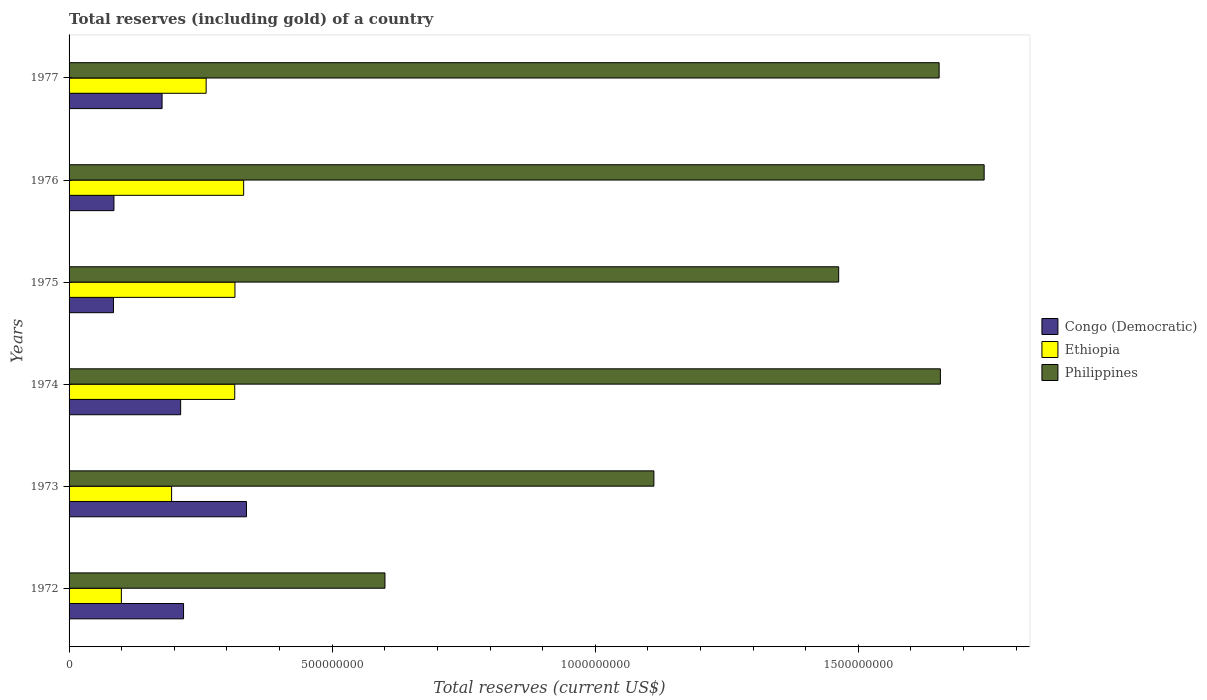How many different coloured bars are there?
Ensure brevity in your answer.  3. Are the number of bars per tick equal to the number of legend labels?
Make the answer very short. Yes. Are the number of bars on each tick of the Y-axis equal?
Keep it short and to the point. Yes. What is the label of the 2nd group of bars from the top?
Provide a succinct answer. 1976. In how many cases, is the number of bars for a given year not equal to the number of legend labels?
Give a very brief answer. 0. What is the total reserves (including gold) in Philippines in 1972?
Your answer should be very brief. 6.00e+08. Across all years, what is the maximum total reserves (including gold) in Congo (Democratic)?
Offer a terse response. 3.37e+08. Across all years, what is the minimum total reserves (including gold) in Congo (Democratic)?
Make the answer very short. 8.44e+07. In which year was the total reserves (including gold) in Philippines maximum?
Offer a very short reply. 1976. What is the total total reserves (including gold) in Congo (Democratic) in the graph?
Your answer should be compact. 1.11e+09. What is the difference between the total reserves (including gold) in Philippines in 1974 and that in 1975?
Your answer should be compact. 1.93e+08. What is the difference between the total reserves (including gold) in Philippines in 1975 and the total reserves (including gold) in Congo (Democratic) in 1976?
Provide a succinct answer. 1.38e+09. What is the average total reserves (including gold) in Philippines per year?
Your answer should be very brief. 1.37e+09. In the year 1975, what is the difference between the total reserves (including gold) in Philippines and total reserves (including gold) in Ethiopia?
Give a very brief answer. 1.15e+09. In how many years, is the total reserves (including gold) in Philippines greater than 500000000 US$?
Your answer should be very brief. 6. What is the ratio of the total reserves (including gold) in Philippines in 1975 to that in 1977?
Make the answer very short. 0.88. Is the total reserves (including gold) in Ethiopia in 1973 less than that in 1976?
Your response must be concise. Yes. What is the difference between the highest and the second highest total reserves (including gold) in Ethiopia?
Give a very brief answer. 1.65e+07. What is the difference between the highest and the lowest total reserves (including gold) in Philippines?
Keep it short and to the point. 1.14e+09. In how many years, is the total reserves (including gold) in Ethiopia greater than the average total reserves (including gold) in Ethiopia taken over all years?
Keep it short and to the point. 4. What does the 3rd bar from the top in 1973 represents?
Your answer should be very brief. Congo (Democratic). What does the 3rd bar from the bottom in 1976 represents?
Give a very brief answer. Philippines. Are all the bars in the graph horizontal?
Provide a short and direct response. Yes. What is the difference between two consecutive major ticks on the X-axis?
Give a very brief answer. 5.00e+08. Are the values on the major ticks of X-axis written in scientific E-notation?
Give a very brief answer. No. Does the graph contain any zero values?
Your response must be concise. No. Does the graph contain grids?
Ensure brevity in your answer.  No. Where does the legend appear in the graph?
Give a very brief answer. Center right. What is the title of the graph?
Your answer should be compact. Total reserves (including gold) of a country. What is the label or title of the X-axis?
Provide a succinct answer. Total reserves (current US$). What is the label or title of the Y-axis?
Keep it short and to the point. Years. What is the Total reserves (current US$) of Congo (Democratic) in 1972?
Your answer should be very brief. 2.18e+08. What is the Total reserves (current US$) of Ethiopia in 1972?
Offer a terse response. 9.94e+07. What is the Total reserves (current US$) in Philippines in 1972?
Ensure brevity in your answer.  6.00e+08. What is the Total reserves (current US$) of Congo (Democratic) in 1973?
Make the answer very short. 3.37e+08. What is the Total reserves (current US$) of Ethiopia in 1973?
Keep it short and to the point. 1.95e+08. What is the Total reserves (current US$) in Philippines in 1973?
Provide a succinct answer. 1.11e+09. What is the Total reserves (current US$) in Congo (Democratic) in 1974?
Your response must be concise. 2.12e+08. What is the Total reserves (current US$) in Ethiopia in 1974?
Your response must be concise. 3.15e+08. What is the Total reserves (current US$) in Philippines in 1974?
Give a very brief answer. 1.66e+09. What is the Total reserves (current US$) in Congo (Democratic) in 1975?
Provide a succinct answer. 8.44e+07. What is the Total reserves (current US$) in Ethiopia in 1975?
Ensure brevity in your answer.  3.15e+08. What is the Total reserves (current US$) of Philippines in 1975?
Your response must be concise. 1.46e+09. What is the Total reserves (current US$) of Congo (Democratic) in 1976?
Provide a succinct answer. 8.53e+07. What is the Total reserves (current US$) of Ethiopia in 1976?
Your answer should be very brief. 3.32e+08. What is the Total reserves (current US$) in Philippines in 1976?
Make the answer very short. 1.74e+09. What is the Total reserves (current US$) of Congo (Democratic) in 1977?
Your answer should be compact. 1.77e+08. What is the Total reserves (current US$) of Ethiopia in 1977?
Give a very brief answer. 2.60e+08. What is the Total reserves (current US$) of Philippines in 1977?
Offer a very short reply. 1.65e+09. Across all years, what is the maximum Total reserves (current US$) in Congo (Democratic)?
Your answer should be very brief. 3.37e+08. Across all years, what is the maximum Total reserves (current US$) in Ethiopia?
Provide a short and direct response. 3.32e+08. Across all years, what is the maximum Total reserves (current US$) of Philippines?
Your response must be concise. 1.74e+09. Across all years, what is the minimum Total reserves (current US$) of Congo (Democratic)?
Provide a short and direct response. 8.44e+07. Across all years, what is the minimum Total reserves (current US$) of Ethiopia?
Offer a terse response. 9.94e+07. Across all years, what is the minimum Total reserves (current US$) in Philippines?
Ensure brevity in your answer.  6.00e+08. What is the total Total reserves (current US$) of Congo (Democratic) in the graph?
Provide a succinct answer. 1.11e+09. What is the total Total reserves (current US$) of Ethiopia in the graph?
Your answer should be compact. 1.52e+09. What is the total Total reserves (current US$) in Philippines in the graph?
Provide a succinct answer. 8.22e+09. What is the difference between the Total reserves (current US$) of Congo (Democratic) in 1972 and that in 1973?
Provide a short and direct response. -1.20e+08. What is the difference between the Total reserves (current US$) in Ethiopia in 1972 and that in 1973?
Provide a succinct answer. -9.55e+07. What is the difference between the Total reserves (current US$) in Philippines in 1972 and that in 1973?
Provide a short and direct response. -5.11e+08. What is the difference between the Total reserves (current US$) in Congo (Democratic) in 1972 and that in 1974?
Ensure brevity in your answer.  5.50e+06. What is the difference between the Total reserves (current US$) in Ethiopia in 1972 and that in 1974?
Your response must be concise. -2.15e+08. What is the difference between the Total reserves (current US$) of Philippines in 1972 and that in 1974?
Offer a terse response. -1.06e+09. What is the difference between the Total reserves (current US$) in Congo (Democratic) in 1972 and that in 1975?
Ensure brevity in your answer.  1.33e+08. What is the difference between the Total reserves (current US$) of Ethiopia in 1972 and that in 1975?
Ensure brevity in your answer.  -2.16e+08. What is the difference between the Total reserves (current US$) in Philippines in 1972 and that in 1975?
Ensure brevity in your answer.  -8.62e+08. What is the difference between the Total reserves (current US$) in Congo (Democratic) in 1972 and that in 1976?
Make the answer very short. 1.32e+08. What is the difference between the Total reserves (current US$) of Ethiopia in 1972 and that in 1976?
Provide a short and direct response. -2.32e+08. What is the difference between the Total reserves (current US$) of Philippines in 1972 and that in 1976?
Keep it short and to the point. -1.14e+09. What is the difference between the Total reserves (current US$) of Congo (Democratic) in 1972 and that in 1977?
Ensure brevity in your answer.  4.08e+07. What is the difference between the Total reserves (current US$) in Ethiopia in 1972 and that in 1977?
Keep it short and to the point. -1.61e+08. What is the difference between the Total reserves (current US$) in Philippines in 1972 and that in 1977?
Your answer should be compact. -1.05e+09. What is the difference between the Total reserves (current US$) of Congo (Democratic) in 1973 and that in 1974?
Your response must be concise. 1.25e+08. What is the difference between the Total reserves (current US$) in Ethiopia in 1973 and that in 1974?
Ensure brevity in your answer.  -1.20e+08. What is the difference between the Total reserves (current US$) in Philippines in 1973 and that in 1974?
Your answer should be very brief. -5.44e+08. What is the difference between the Total reserves (current US$) in Congo (Democratic) in 1973 and that in 1975?
Provide a succinct answer. 2.53e+08. What is the difference between the Total reserves (current US$) in Ethiopia in 1973 and that in 1975?
Your answer should be very brief. -1.20e+08. What is the difference between the Total reserves (current US$) in Philippines in 1973 and that in 1975?
Give a very brief answer. -3.51e+08. What is the difference between the Total reserves (current US$) of Congo (Democratic) in 1973 and that in 1976?
Your answer should be compact. 2.52e+08. What is the difference between the Total reserves (current US$) of Ethiopia in 1973 and that in 1976?
Your response must be concise. -1.37e+08. What is the difference between the Total reserves (current US$) of Philippines in 1973 and that in 1976?
Keep it short and to the point. -6.28e+08. What is the difference between the Total reserves (current US$) of Congo (Democratic) in 1973 and that in 1977?
Provide a short and direct response. 1.60e+08. What is the difference between the Total reserves (current US$) of Ethiopia in 1973 and that in 1977?
Your answer should be very brief. -6.56e+07. What is the difference between the Total reserves (current US$) of Philippines in 1973 and that in 1977?
Your answer should be compact. -5.42e+08. What is the difference between the Total reserves (current US$) in Congo (Democratic) in 1974 and that in 1975?
Provide a succinct answer. 1.28e+08. What is the difference between the Total reserves (current US$) of Ethiopia in 1974 and that in 1975?
Provide a succinct answer. -4.15e+05. What is the difference between the Total reserves (current US$) in Philippines in 1974 and that in 1975?
Give a very brief answer. 1.93e+08. What is the difference between the Total reserves (current US$) in Congo (Democratic) in 1974 and that in 1976?
Keep it short and to the point. 1.27e+08. What is the difference between the Total reserves (current US$) in Ethiopia in 1974 and that in 1976?
Ensure brevity in your answer.  -1.70e+07. What is the difference between the Total reserves (current US$) of Philippines in 1974 and that in 1976?
Offer a very short reply. -8.32e+07. What is the difference between the Total reserves (current US$) in Congo (Democratic) in 1974 and that in 1977?
Your answer should be very brief. 3.53e+07. What is the difference between the Total reserves (current US$) of Ethiopia in 1974 and that in 1977?
Your answer should be compact. 5.43e+07. What is the difference between the Total reserves (current US$) in Philippines in 1974 and that in 1977?
Give a very brief answer. 2.32e+06. What is the difference between the Total reserves (current US$) in Congo (Democratic) in 1975 and that in 1976?
Make the answer very short. -9.39e+05. What is the difference between the Total reserves (current US$) in Ethiopia in 1975 and that in 1976?
Provide a short and direct response. -1.65e+07. What is the difference between the Total reserves (current US$) of Philippines in 1975 and that in 1976?
Your answer should be compact. -2.76e+08. What is the difference between the Total reserves (current US$) in Congo (Democratic) in 1975 and that in 1977?
Keep it short and to the point. -9.24e+07. What is the difference between the Total reserves (current US$) of Ethiopia in 1975 and that in 1977?
Provide a short and direct response. 5.48e+07. What is the difference between the Total reserves (current US$) of Philippines in 1975 and that in 1977?
Give a very brief answer. -1.91e+08. What is the difference between the Total reserves (current US$) in Congo (Democratic) in 1976 and that in 1977?
Your response must be concise. -9.14e+07. What is the difference between the Total reserves (current US$) in Ethiopia in 1976 and that in 1977?
Keep it short and to the point. 7.13e+07. What is the difference between the Total reserves (current US$) of Philippines in 1976 and that in 1977?
Your answer should be very brief. 8.56e+07. What is the difference between the Total reserves (current US$) of Congo (Democratic) in 1972 and the Total reserves (current US$) of Ethiopia in 1973?
Provide a succinct answer. 2.27e+07. What is the difference between the Total reserves (current US$) in Congo (Democratic) in 1972 and the Total reserves (current US$) in Philippines in 1973?
Your answer should be compact. -8.94e+08. What is the difference between the Total reserves (current US$) of Ethiopia in 1972 and the Total reserves (current US$) of Philippines in 1973?
Your answer should be very brief. -1.01e+09. What is the difference between the Total reserves (current US$) of Congo (Democratic) in 1972 and the Total reserves (current US$) of Ethiopia in 1974?
Your response must be concise. -9.73e+07. What is the difference between the Total reserves (current US$) in Congo (Democratic) in 1972 and the Total reserves (current US$) in Philippines in 1974?
Provide a short and direct response. -1.44e+09. What is the difference between the Total reserves (current US$) in Ethiopia in 1972 and the Total reserves (current US$) in Philippines in 1974?
Offer a very short reply. -1.56e+09. What is the difference between the Total reserves (current US$) of Congo (Democratic) in 1972 and the Total reserves (current US$) of Ethiopia in 1975?
Provide a short and direct response. -9.77e+07. What is the difference between the Total reserves (current US$) of Congo (Democratic) in 1972 and the Total reserves (current US$) of Philippines in 1975?
Provide a succinct answer. -1.25e+09. What is the difference between the Total reserves (current US$) in Ethiopia in 1972 and the Total reserves (current US$) in Philippines in 1975?
Ensure brevity in your answer.  -1.36e+09. What is the difference between the Total reserves (current US$) of Congo (Democratic) in 1972 and the Total reserves (current US$) of Ethiopia in 1976?
Make the answer very short. -1.14e+08. What is the difference between the Total reserves (current US$) of Congo (Democratic) in 1972 and the Total reserves (current US$) of Philippines in 1976?
Provide a succinct answer. -1.52e+09. What is the difference between the Total reserves (current US$) of Ethiopia in 1972 and the Total reserves (current US$) of Philippines in 1976?
Offer a very short reply. -1.64e+09. What is the difference between the Total reserves (current US$) of Congo (Democratic) in 1972 and the Total reserves (current US$) of Ethiopia in 1977?
Your answer should be compact. -4.29e+07. What is the difference between the Total reserves (current US$) of Congo (Democratic) in 1972 and the Total reserves (current US$) of Philippines in 1977?
Keep it short and to the point. -1.44e+09. What is the difference between the Total reserves (current US$) of Ethiopia in 1972 and the Total reserves (current US$) of Philippines in 1977?
Keep it short and to the point. -1.55e+09. What is the difference between the Total reserves (current US$) of Congo (Democratic) in 1973 and the Total reserves (current US$) of Ethiopia in 1974?
Make the answer very short. 2.23e+07. What is the difference between the Total reserves (current US$) in Congo (Democratic) in 1973 and the Total reserves (current US$) in Philippines in 1974?
Your answer should be compact. -1.32e+09. What is the difference between the Total reserves (current US$) in Ethiopia in 1973 and the Total reserves (current US$) in Philippines in 1974?
Ensure brevity in your answer.  -1.46e+09. What is the difference between the Total reserves (current US$) of Congo (Democratic) in 1973 and the Total reserves (current US$) of Ethiopia in 1975?
Make the answer very short. 2.19e+07. What is the difference between the Total reserves (current US$) in Congo (Democratic) in 1973 and the Total reserves (current US$) in Philippines in 1975?
Offer a very short reply. -1.13e+09. What is the difference between the Total reserves (current US$) in Ethiopia in 1973 and the Total reserves (current US$) in Philippines in 1975?
Offer a very short reply. -1.27e+09. What is the difference between the Total reserves (current US$) of Congo (Democratic) in 1973 and the Total reserves (current US$) of Ethiopia in 1976?
Provide a succinct answer. 5.34e+06. What is the difference between the Total reserves (current US$) of Congo (Democratic) in 1973 and the Total reserves (current US$) of Philippines in 1976?
Keep it short and to the point. -1.40e+09. What is the difference between the Total reserves (current US$) in Ethiopia in 1973 and the Total reserves (current US$) in Philippines in 1976?
Give a very brief answer. -1.54e+09. What is the difference between the Total reserves (current US$) of Congo (Democratic) in 1973 and the Total reserves (current US$) of Ethiopia in 1977?
Provide a succinct answer. 7.66e+07. What is the difference between the Total reserves (current US$) in Congo (Democratic) in 1973 and the Total reserves (current US$) in Philippines in 1977?
Keep it short and to the point. -1.32e+09. What is the difference between the Total reserves (current US$) in Ethiopia in 1973 and the Total reserves (current US$) in Philippines in 1977?
Offer a terse response. -1.46e+09. What is the difference between the Total reserves (current US$) in Congo (Democratic) in 1974 and the Total reserves (current US$) in Ethiopia in 1975?
Keep it short and to the point. -1.03e+08. What is the difference between the Total reserves (current US$) in Congo (Democratic) in 1974 and the Total reserves (current US$) in Philippines in 1975?
Give a very brief answer. -1.25e+09. What is the difference between the Total reserves (current US$) in Ethiopia in 1974 and the Total reserves (current US$) in Philippines in 1975?
Offer a terse response. -1.15e+09. What is the difference between the Total reserves (current US$) in Congo (Democratic) in 1974 and the Total reserves (current US$) in Ethiopia in 1976?
Your answer should be compact. -1.20e+08. What is the difference between the Total reserves (current US$) of Congo (Democratic) in 1974 and the Total reserves (current US$) of Philippines in 1976?
Your answer should be very brief. -1.53e+09. What is the difference between the Total reserves (current US$) of Ethiopia in 1974 and the Total reserves (current US$) of Philippines in 1976?
Provide a succinct answer. -1.42e+09. What is the difference between the Total reserves (current US$) in Congo (Democratic) in 1974 and the Total reserves (current US$) in Ethiopia in 1977?
Provide a succinct answer. -4.84e+07. What is the difference between the Total reserves (current US$) in Congo (Democratic) in 1974 and the Total reserves (current US$) in Philippines in 1977?
Keep it short and to the point. -1.44e+09. What is the difference between the Total reserves (current US$) in Ethiopia in 1974 and the Total reserves (current US$) in Philippines in 1977?
Give a very brief answer. -1.34e+09. What is the difference between the Total reserves (current US$) of Congo (Democratic) in 1975 and the Total reserves (current US$) of Ethiopia in 1976?
Make the answer very short. -2.47e+08. What is the difference between the Total reserves (current US$) of Congo (Democratic) in 1975 and the Total reserves (current US$) of Philippines in 1976?
Make the answer very short. -1.65e+09. What is the difference between the Total reserves (current US$) in Ethiopia in 1975 and the Total reserves (current US$) in Philippines in 1976?
Your answer should be very brief. -1.42e+09. What is the difference between the Total reserves (current US$) of Congo (Democratic) in 1975 and the Total reserves (current US$) of Ethiopia in 1977?
Your answer should be very brief. -1.76e+08. What is the difference between the Total reserves (current US$) of Congo (Democratic) in 1975 and the Total reserves (current US$) of Philippines in 1977?
Make the answer very short. -1.57e+09. What is the difference between the Total reserves (current US$) in Ethiopia in 1975 and the Total reserves (current US$) in Philippines in 1977?
Your answer should be very brief. -1.34e+09. What is the difference between the Total reserves (current US$) of Congo (Democratic) in 1976 and the Total reserves (current US$) of Ethiopia in 1977?
Ensure brevity in your answer.  -1.75e+08. What is the difference between the Total reserves (current US$) of Congo (Democratic) in 1976 and the Total reserves (current US$) of Philippines in 1977?
Provide a short and direct response. -1.57e+09. What is the difference between the Total reserves (current US$) of Ethiopia in 1976 and the Total reserves (current US$) of Philippines in 1977?
Provide a succinct answer. -1.32e+09. What is the average Total reserves (current US$) of Congo (Democratic) per year?
Your answer should be compact. 1.86e+08. What is the average Total reserves (current US$) in Ethiopia per year?
Make the answer very short. 2.53e+08. What is the average Total reserves (current US$) of Philippines per year?
Offer a very short reply. 1.37e+09. In the year 1972, what is the difference between the Total reserves (current US$) of Congo (Democratic) and Total reserves (current US$) of Ethiopia?
Ensure brevity in your answer.  1.18e+08. In the year 1972, what is the difference between the Total reserves (current US$) in Congo (Democratic) and Total reserves (current US$) in Philippines?
Offer a terse response. -3.83e+08. In the year 1972, what is the difference between the Total reserves (current US$) of Ethiopia and Total reserves (current US$) of Philippines?
Ensure brevity in your answer.  -5.01e+08. In the year 1973, what is the difference between the Total reserves (current US$) in Congo (Democratic) and Total reserves (current US$) in Ethiopia?
Provide a succinct answer. 1.42e+08. In the year 1973, what is the difference between the Total reserves (current US$) in Congo (Democratic) and Total reserves (current US$) in Philippines?
Give a very brief answer. -7.74e+08. In the year 1973, what is the difference between the Total reserves (current US$) in Ethiopia and Total reserves (current US$) in Philippines?
Your answer should be compact. -9.17e+08. In the year 1974, what is the difference between the Total reserves (current US$) of Congo (Democratic) and Total reserves (current US$) of Ethiopia?
Offer a terse response. -1.03e+08. In the year 1974, what is the difference between the Total reserves (current US$) of Congo (Democratic) and Total reserves (current US$) of Philippines?
Your answer should be very brief. -1.44e+09. In the year 1974, what is the difference between the Total reserves (current US$) of Ethiopia and Total reserves (current US$) of Philippines?
Your response must be concise. -1.34e+09. In the year 1975, what is the difference between the Total reserves (current US$) in Congo (Democratic) and Total reserves (current US$) in Ethiopia?
Provide a succinct answer. -2.31e+08. In the year 1975, what is the difference between the Total reserves (current US$) of Congo (Democratic) and Total reserves (current US$) of Philippines?
Provide a succinct answer. -1.38e+09. In the year 1975, what is the difference between the Total reserves (current US$) in Ethiopia and Total reserves (current US$) in Philippines?
Give a very brief answer. -1.15e+09. In the year 1976, what is the difference between the Total reserves (current US$) of Congo (Democratic) and Total reserves (current US$) of Ethiopia?
Make the answer very short. -2.46e+08. In the year 1976, what is the difference between the Total reserves (current US$) in Congo (Democratic) and Total reserves (current US$) in Philippines?
Keep it short and to the point. -1.65e+09. In the year 1976, what is the difference between the Total reserves (current US$) in Ethiopia and Total reserves (current US$) in Philippines?
Keep it short and to the point. -1.41e+09. In the year 1977, what is the difference between the Total reserves (current US$) of Congo (Democratic) and Total reserves (current US$) of Ethiopia?
Keep it short and to the point. -8.37e+07. In the year 1977, what is the difference between the Total reserves (current US$) of Congo (Democratic) and Total reserves (current US$) of Philippines?
Provide a short and direct response. -1.48e+09. In the year 1977, what is the difference between the Total reserves (current US$) in Ethiopia and Total reserves (current US$) in Philippines?
Keep it short and to the point. -1.39e+09. What is the ratio of the Total reserves (current US$) of Congo (Democratic) in 1972 to that in 1973?
Offer a very short reply. 0.65. What is the ratio of the Total reserves (current US$) of Ethiopia in 1972 to that in 1973?
Your answer should be very brief. 0.51. What is the ratio of the Total reserves (current US$) in Philippines in 1972 to that in 1973?
Your answer should be very brief. 0.54. What is the ratio of the Total reserves (current US$) of Congo (Democratic) in 1972 to that in 1974?
Offer a terse response. 1.03. What is the ratio of the Total reserves (current US$) of Ethiopia in 1972 to that in 1974?
Your answer should be very brief. 0.32. What is the ratio of the Total reserves (current US$) in Philippines in 1972 to that in 1974?
Your response must be concise. 0.36. What is the ratio of the Total reserves (current US$) in Congo (Democratic) in 1972 to that in 1975?
Make the answer very short. 2.58. What is the ratio of the Total reserves (current US$) of Ethiopia in 1972 to that in 1975?
Your answer should be very brief. 0.32. What is the ratio of the Total reserves (current US$) of Philippines in 1972 to that in 1975?
Your answer should be very brief. 0.41. What is the ratio of the Total reserves (current US$) in Congo (Democratic) in 1972 to that in 1976?
Give a very brief answer. 2.55. What is the ratio of the Total reserves (current US$) in Ethiopia in 1972 to that in 1976?
Your answer should be very brief. 0.3. What is the ratio of the Total reserves (current US$) in Philippines in 1972 to that in 1976?
Provide a short and direct response. 0.35. What is the ratio of the Total reserves (current US$) of Congo (Democratic) in 1972 to that in 1977?
Give a very brief answer. 1.23. What is the ratio of the Total reserves (current US$) in Ethiopia in 1972 to that in 1977?
Provide a short and direct response. 0.38. What is the ratio of the Total reserves (current US$) in Philippines in 1972 to that in 1977?
Offer a terse response. 0.36. What is the ratio of the Total reserves (current US$) of Congo (Democratic) in 1973 to that in 1974?
Provide a succinct answer. 1.59. What is the ratio of the Total reserves (current US$) of Ethiopia in 1973 to that in 1974?
Make the answer very short. 0.62. What is the ratio of the Total reserves (current US$) in Philippines in 1973 to that in 1974?
Provide a succinct answer. 0.67. What is the ratio of the Total reserves (current US$) of Congo (Democratic) in 1973 to that in 1975?
Ensure brevity in your answer.  4. What is the ratio of the Total reserves (current US$) in Ethiopia in 1973 to that in 1975?
Give a very brief answer. 0.62. What is the ratio of the Total reserves (current US$) in Philippines in 1973 to that in 1975?
Offer a very short reply. 0.76. What is the ratio of the Total reserves (current US$) of Congo (Democratic) in 1973 to that in 1976?
Ensure brevity in your answer.  3.95. What is the ratio of the Total reserves (current US$) of Ethiopia in 1973 to that in 1976?
Your answer should be very brief. 0.59. What is the ratio of the Total reserves (current US$) of Philippines in 1973 to that in 1976?
Provide a succinct answer. 0.64. What is the ratio of the Total reserves (current US$) in Congo (Democratic) in 1973 to that in 1977?
Give a very brief answer. 1.91. What is the ratio of the Total reserves (current US$) in Ethiopia in 1973 to that in 1977?
Your answer should be compact. 0.75. What is the ratio of the Total reserves (current US$) in Philippines in 1973 to that in 1977?
Keep it short and to the point. 0.67. What is the ratio of the Total reserves (current US$) in Congo (Democratic) in 1974 to that in 1975?
Give a very brief answer. 2.51. What is the ratio of the Total reserves (current US$) of Philippines in 1974 to that in 1975?
Your response must be concise. 1.13. What is the ratio of the Total reserves (current US$) in Congo (Democratic) in 1974 to that in 1976?
Offer a very short reply. 2.49. What is the ratio of the Total reserves (current US$) in Ethiopia in 1974 to that in 1976?
Your response must be concise. 0.95. What is the ratio of the Total reserves (current US$) of Philippines in 1974 to that in 1976?
Make the answer very short. 0.95. What is the ratio of the Total reserves (current US$) of Congo (Democratic) in 1974 to that in 1977?
Your response must be concise. 1.2. What is the ratio of the Total reserves (current US$) in Ethiopia in 1974 to that in 1977?
Offer a very short reply. 1.21. What is the ratio of the Total reserves (current US$) in Philippines in 1974 to that in 1977?
Offer a terse response. 1. What is the ratio of the Total reserves (current US$) of Congo (Democratic) in 1975 to that in 1976?
Provide a short and direct response. 0.99. What is the ratio of the Total reserves (current US$) of Ethiopia in 1975 to that in 1976?
Provide a short and direct response. 0.95. What is the ratio of the Total reserves (current US$) in Philippines in 1975 to that in 1976?
Offer a very short reply. 0.84. What is the ratio of the Total reserves (current US$) of Congo (Democratic) in 1975 to that in 1977?
Provide a succinct answer. 0.48. What is the ratio of the Total reserves (current US$) in Ethiopia in 1975 to that in 1977?
Your answer should be very brief. 1.21. What is the ratio of the Total reserves (current US$) of Philippines in 1975 to that in 1977?
Provide a short and direct response. 0.88. What is the ratio of the Total reserves (current US$) in Congo (Democratic) in 1976 to that in 1977?
Your answer should be very brief. 0.48. What is the ratio of the Total reserves (current US$) in Ethiopia in 1976 to that in 1977?
Ensure brevity in your answer.  1.27. What is the ratio of the Total reserves (current US$) in Philippines in 1976 to that in 1977?
Make the answer very short. 1.05. What is the difference between the highest and the second highest Total reserves (current US$) of Congo (Democratic)?
Your response must be concise. 1.20e+08. What is the difference between the highest and the second highest Total reserves (current US$) in Ethiopia?
Offer a very short reply. 1.65e+07. What is the difference between the highest and the second highest Total reserves (current US$) in Philippines?
Your response must be concise. 8.32e+07. What is the difference between the highest and the lowest Total reserves (current US$) in Congo (Democratic)?
Make the answer very short. 2.53e+08. What is the difference between the highest and the lowest Total reserves (current US$) in Ethiopia?
Offer a very short reply. 2.32e+08. What is the difference between the highest and the lowest Total reserves (current US$) of Philippines?
Offer a very short reply. 1.14e+09. 